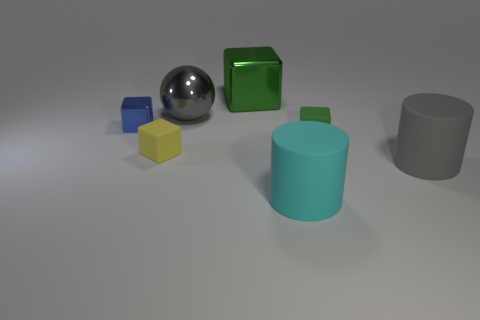Are there an equal number of yellow things that are right of the big green metal thing and large cyan objects?
Your answer should be compact. No. How big is the object that is on the left side of the gray ball and in front of the small green thing?
Keep it short and to the point. Small. There is a large cylinder to the right of the matte block that is to the right of the small yellow matte object; what is its color?
Keep it short and to the point. Gray. How many yellow things are tiny matte things or rubber cylinders?
Keep it short and to the point. 1. What color is the cube that is on the left side of the large cyan cylinder and to the right of the tiny yellow block?
Make the answer very short. Green. What number of tiny objects are blue things or green matte balls?
Make the answer very short. 1. The blue metallic object that is the same shape as the yellow rubber object is what size?
Offer a terse response. Small. What is the shape of the big gray metal thing?
Give a very brief answer. Sphere. Is the big gray cylinder made of the same material as the green block behind the tiny blue metallic cube?
Your answer should be very brief. No. What number of shiny objects are either cylinders or yellow objects?
Offer a terse response. 0. 